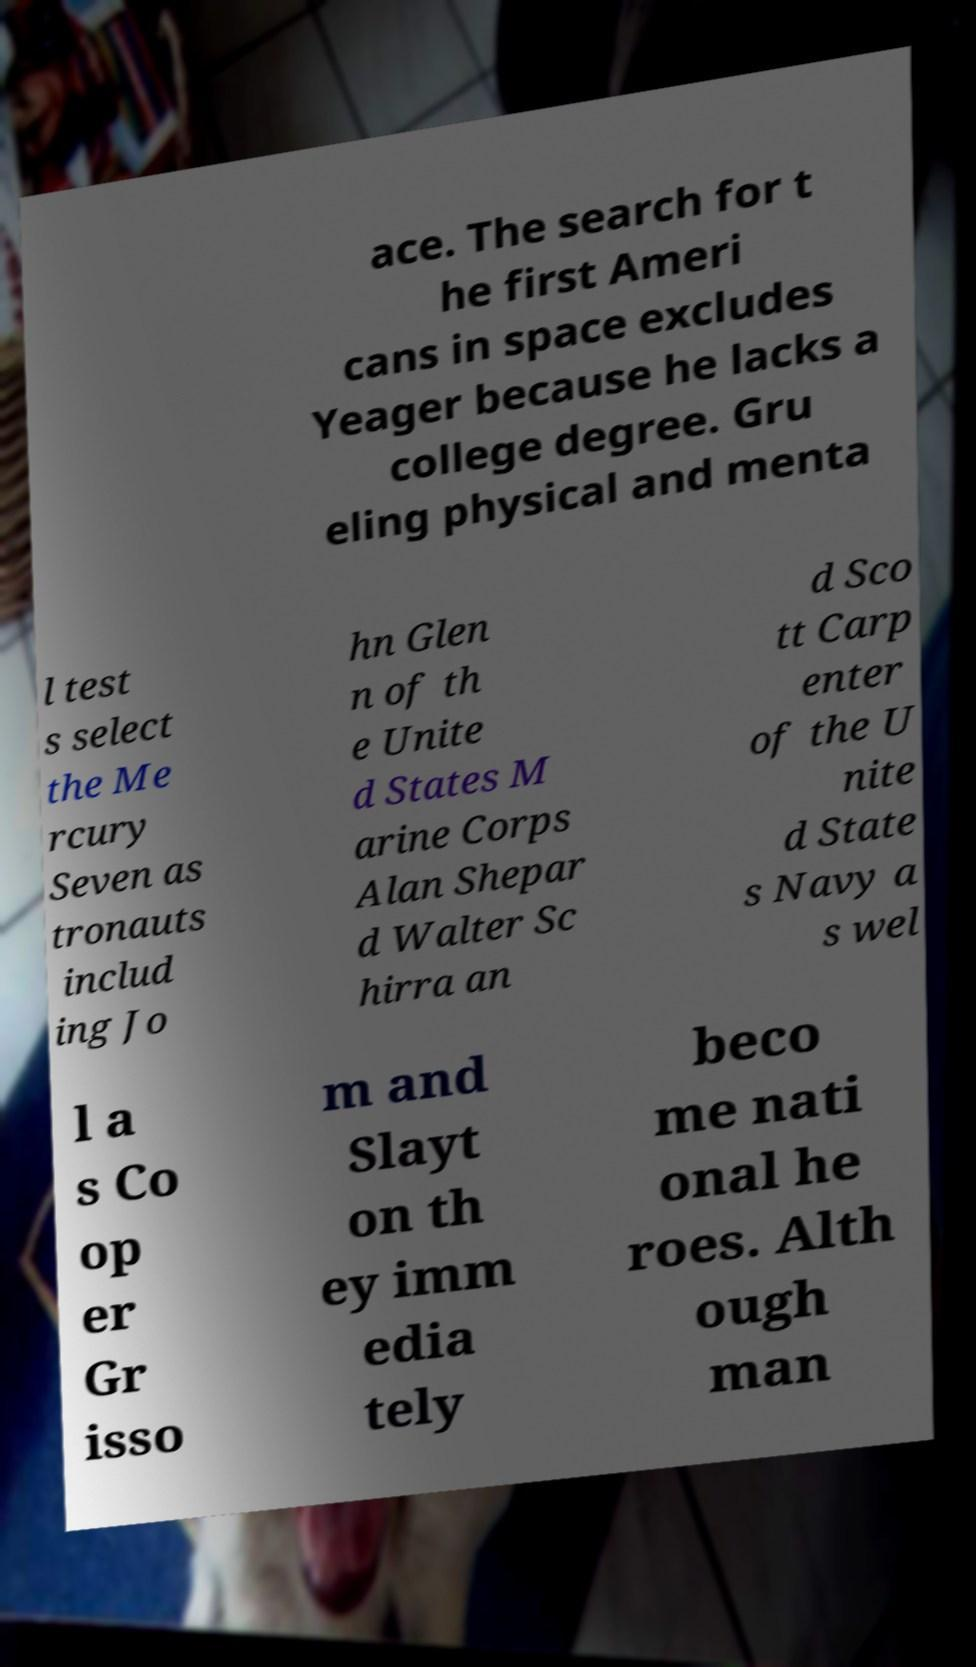There's text embedded in this image that I need extracted. Can you transcribe it verbatim? ace. The search for t he first Ameri cans in space excludes Yeager because he lacks a college degree. Gru eling physical and menta l test s select the Me rcury Seven as tronauts includ ing Jo hn Glen n of th e Unite d States M arine Corps Alan Shepar d Walter Sc hirra an d Sco tt Carp enter of the U nite d State s Navy a s wel l a s Co op er Gr isso m and Slayt on th ey imm edia tely beco me nati onal he roes. Alth ough man 